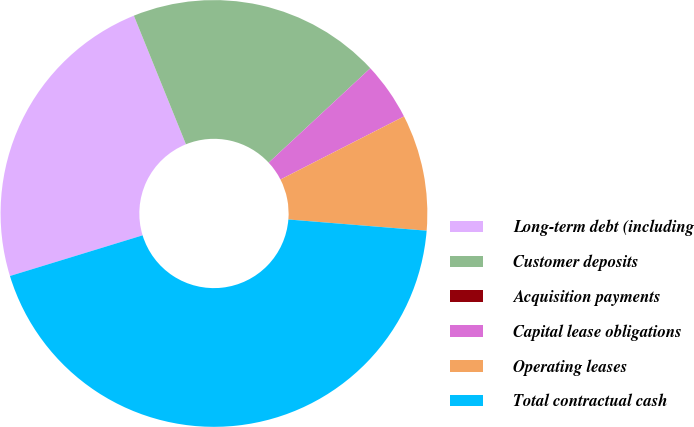Convert chart to OTSL. <chart><loc_0><loc_0><loc_500><loc_500><pie_chart><fcel>Long-term debt (including<fcel>Customer deposits<fcel>Acquisition payments<fcel>Capital lease obligations<fcel>Operating leases<fcel>Total contractual cash<nl><fcel>23.61%<fcel>19.21%<fcel>0.0%<fcel>4.4%<fcel>8.8%<fcel>43.98%<nl></chart> 